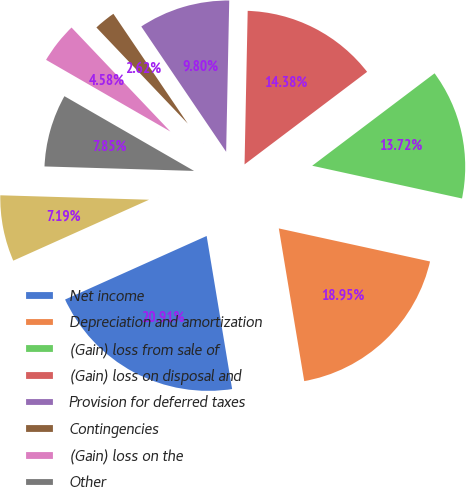Convert chart to OTSL. <chart><loc_0><loc_0><loc_500><loc_500><pie_chart><fcel>Net income<fcel>Depreciation and amortization<fcel>(Gain) loss from sale of<fcel>(Gain) loss on disposal and<fcel>Provision for deferred taxes<fcel>Contingencies<fcel>(Gain) loss on the<fcel>Other<fcel>(Increase) decrease in<nl><fcel>20.91%<fcel>18.95%<fcel>13.72%<fcel>14.38%<fcel>9.8%<fcel>2.62%<fcel>4.58%<fcel>7.85%<fcel>7.19%<nl></chart> 